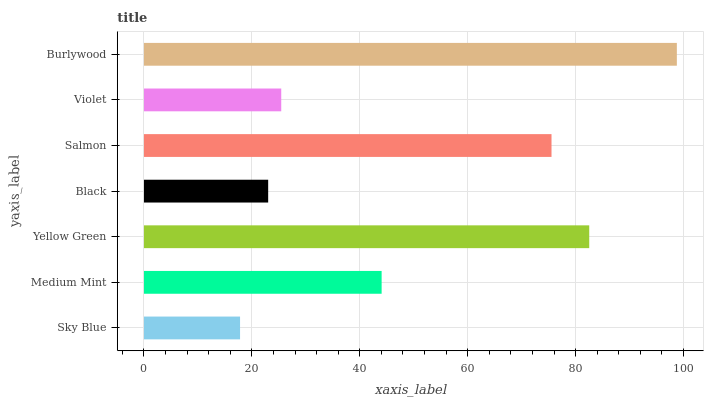Is Sky Blue the minimum?
Answer yes or no. Yes. Is Burlywood the maximum?
Answer yes or no. Yes. Is Medium Mint the minimum?
Answer yes or no. No. Is Medium Mint the maximum?
Answer yes or no. No. Is Medium Mint greater than Sky Blue?
Answer yes or no. Yes. Is Sky Blue less than Medium Mint?
Answer yes or no. Yes. Is Sky Blue greater than Medium Mint?
Answer yes or no. No. Is Medium Mint less than Sky Blue?
Answer yes or no. No. Is Medium Mint the high median?
Answer yes or no. Yes. Is Medium Mint the low median?
Answer yes or no. Yes. Is Sky Blue the high median?
Answer yes or no. No. Is Yellow Green the low median?
Answer yes or no. No. 